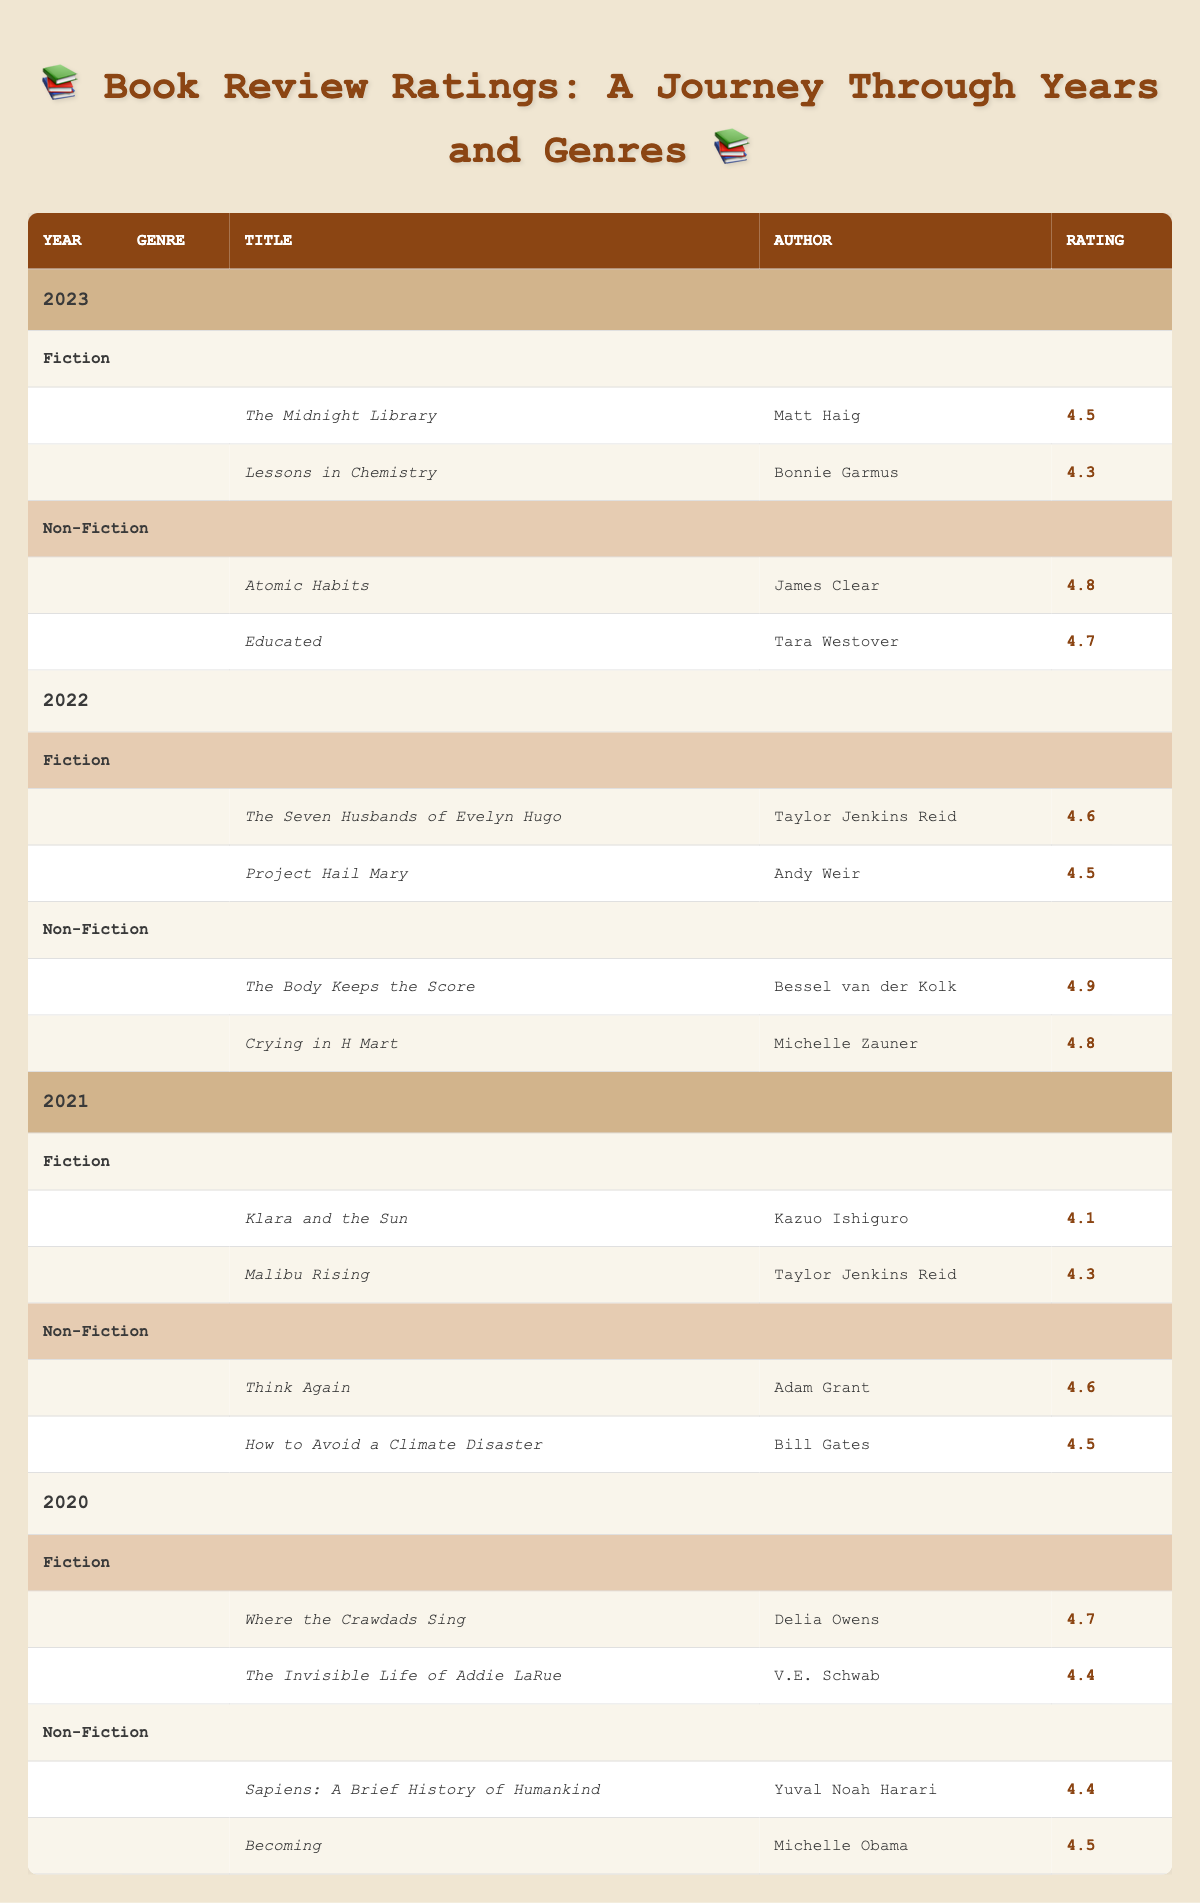What is the highest rating for a Fiction book published in 2022? The highest rating in the Fiction category for the year 2022 is found by comparing the ratings of "The Seven Husbands of Evelyn Hugo" (4.6) and "Project Hail Mary" (4.5). The maximum rating is 4.6.
Answer: 4.6 What is the average rating of Non-Fiction books published in 2021? The Non-Fiction books in 2021 are "Think Again" (4.6) and "How to Avoid a Climate Disaster" (4.5). To find the average, add the two ratings (4.6 + 4.5 = 9.1) and divide by 2, which gives 9.1 / 2 = 4.55.
Answer: 4.55 Did any Fiction book published in 2020 receive a rating higher than 4.5? The Fiction ratings for 2020 include "Where the Crawdads Sing" (4.7) and "The Invisible Life of Addie LaRue" (4.4). Since 4.7 is greater than 4.5, the answer is yes.
Answer: Yes Which genre had a higher average rating in 2023, Fiction or Non-Fiction? For Fiction in 2023, the ratings are 4.5 and 4.3, resulting in an average of (4.5 + 4.3) / 2 = 4.4. For Non-Fiction, the ratings are 4.8 and 4.7, resulting in (4.8 + 4.7) / 2 = 4.75. Since 4.75 > 4.4, Non-Fiction has a higher average rating.
Answer: Non-Fiction How many Non-Fiction books have a rating of 4.5 or higher published between 2020 and 2023? The Non-Fiction books with ratings of 4.5 or higher are "Atomic Habits" (4.8), "Educated" (4.7), "The Body Keeps the Score" (4.9), "Crying in H Mart" (4.8), "Think Again" (4.6), "How to Avoid a Climate Disaster" (4.5), "Sapiens" (4.4), and "Becoming" (4.5). Counting these gives a total of 7 books.
Answer: 7 